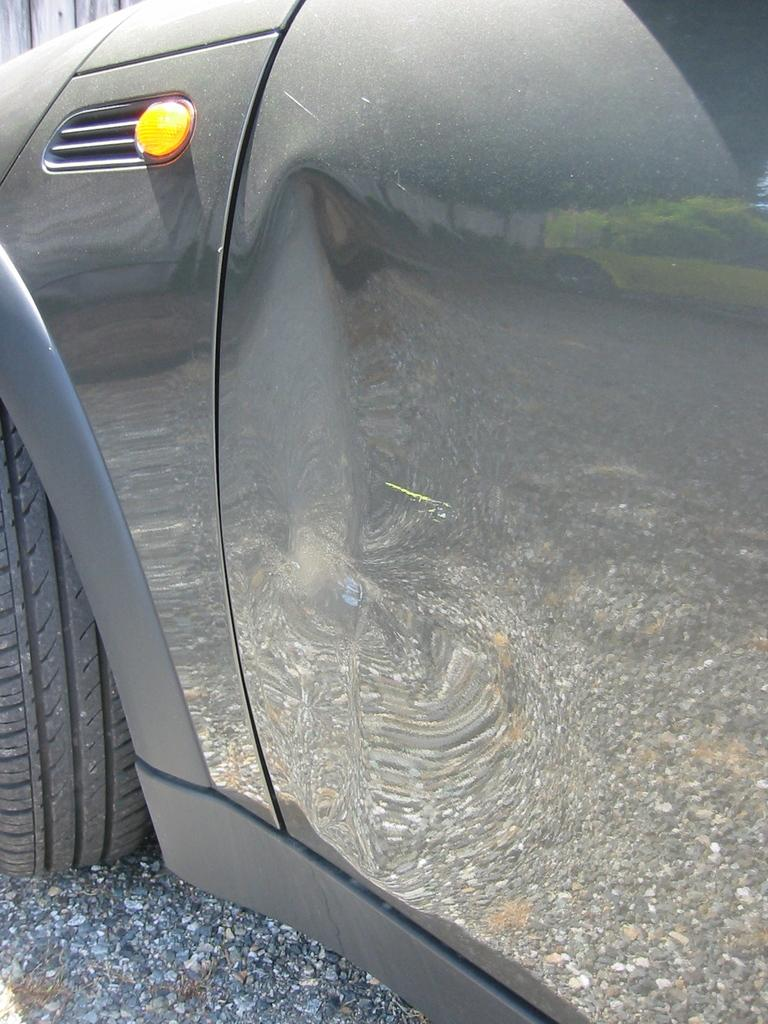What is the main subject of the image? The main subject of the image is a car. What can be seen in the background of the image? There is a road visible in the image. What type of pollution can be seen coming from the car in the image? There is no indication of pollution in the image, as it only features a car and a road. How does the car blow air in the image? The image does not show the car blowing air; it only shows the car and the road. 